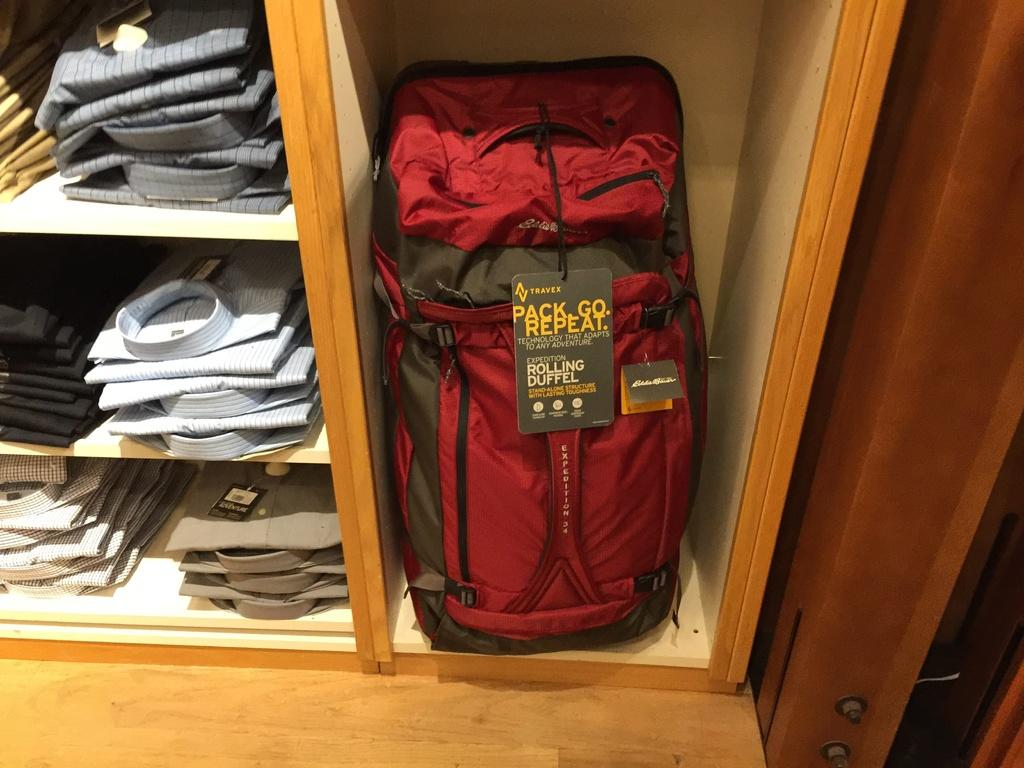What object is located on the right side of the image? There is a piece of luggage on the right side of the image. What type of clothing can be seen on the left side of the image? There are shirts on the left side of the image. How many sticks are visible in the image? There are no sticks present in the image. Are there any ants crawling on the shirts in the image? There is no mention of ants in the image, and therefore no such activity can be observed. 